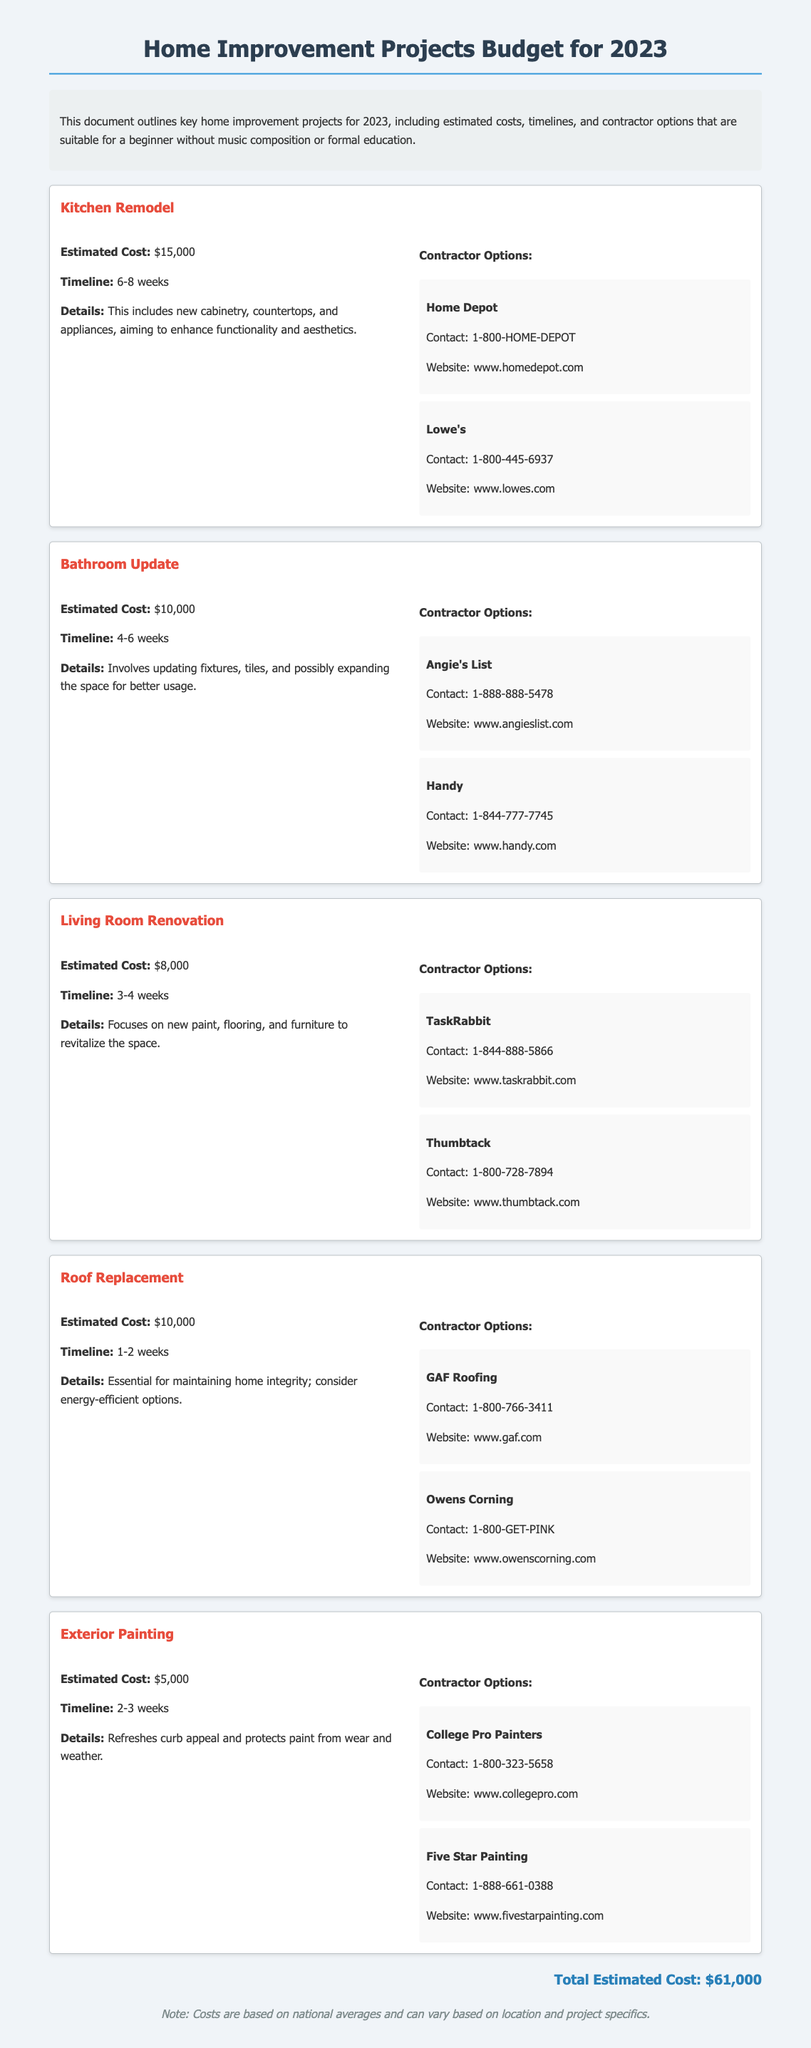What is the estimated cost for the Kitchen Remodel? The estimated cost for the Kitchen Remodel is specifically stated in the project details section.
Answer: $15,000 How long is the timeline for the Bathroom Update? The timeline for the Bathroom Update is provided in the document and shows the expected duration.
Answer: 4-6 weeks What are the two contractor options for the Living Room Renovation? The document lists contractor options under the Living Room Renovation section.
Answer: TaskRabbit, Thumbtack What is the estimated cost for the Roof Replacement? The estimated cost for the Roof Replacement is mentioned in the project details and is clearly defined.
Answer: $10,000 How much is the total estimated cost for all projects? The total estimated cost is summarized at the end of the document and is the sum of all individual project costs.
Answer: $61,000 Which contractor option offers a contact number for Angie's List? The document provides contact details for contractor options, specifying the contact number for Angie's List.
Answer: 1-888-888-5478 What is the timeline for the Exterior Painting project? The timeline for the Exterior Painting project is mentioned with a specific duration in the project details section.
Answer: 2-3 weeks What is one of the details included in the Kitchen Remodel? The details for the Kitchen Remodel provide insights into what the project includes and can be found under the project description.
Answer: New cabinetry, countertops, and appliances 